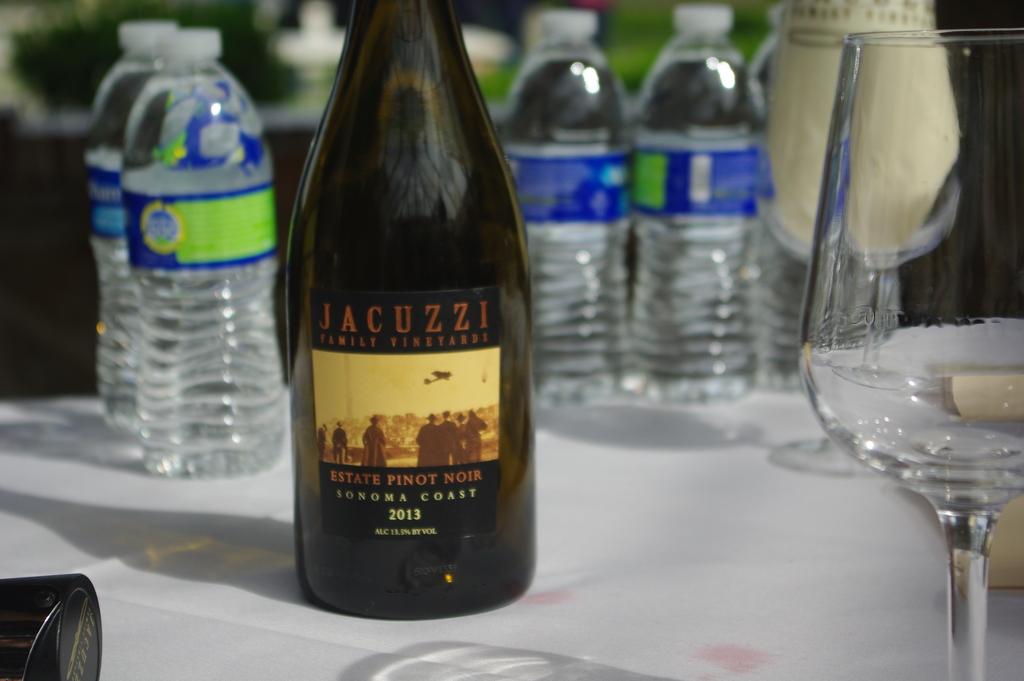When was this wine made?
Provide a short and direct response. 2013. What type of wine is this?
Your answer should be compact. Pinot noir. 